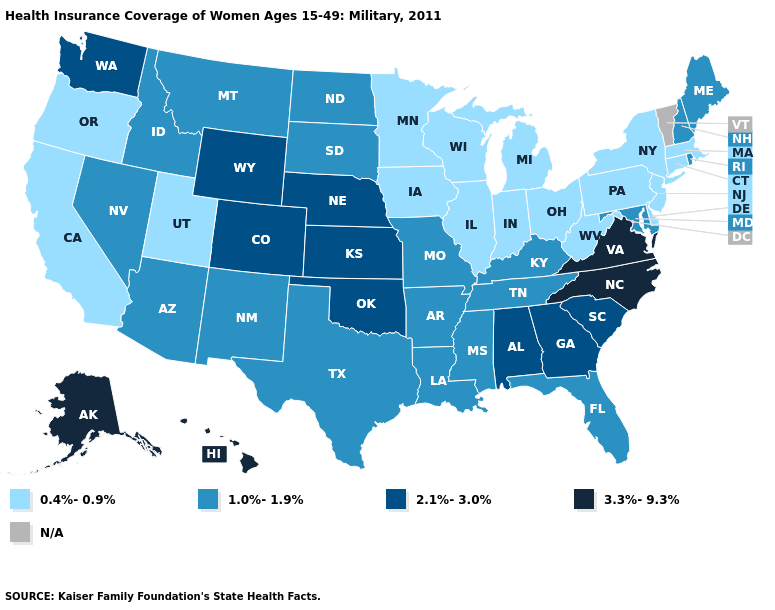Does the map have missing data?
Write a very short answer. Yes. Name the states that have a value in the range 1.0%-1.9%?
Short answer required. Arizona, Arkansas, Florida, Idaho, Kentucky, Louisiana, Maine, Maryland, Mississippi, Missouri, Montana, Nevada, New Hampshire, New Mexico, North Dakota, Rhode Island, South Dakota, Tennessee, Texas. Name the states that have a value in the range 3.3%-9.3%?
Keep it brief. Alaska, Hawaii, North Carolina, Virginia. What is the lowest value in states that border Ohio?
Quick response, please. 0.4%-0.9%. What is the highest value in states that border Colorado?
Short answer required. 2.1%-3.0%. Does North Dakota have the highest value in the MidWest?
Quick response, please. No. Does the first symbol in the legend represent the smallest category?
Short answer required. Yes. Does the first symbol in the legend represent the smallest category?
Quick response, please. Yes. Name the states that have a value in the range 3.3%-9.3%?
Short answer required. Alaska, Hawaii, North Carolina, Virginia. Name the states that have a value in the range N/A?
Keep it brief. Vermont. What is the value of Nebraska?
Concise answer only. 2.1%-3.0%. What is the lowest value in the West?
Answer briefly. 0.4%-0.9%. Name the states that have a value in the range 2.1%-3.0%?
Concise answer only. Alabama, Colorado, Georgia, Kansas, Nebraska, Oklahoma, South Carolina, Washington, Wyoming. 